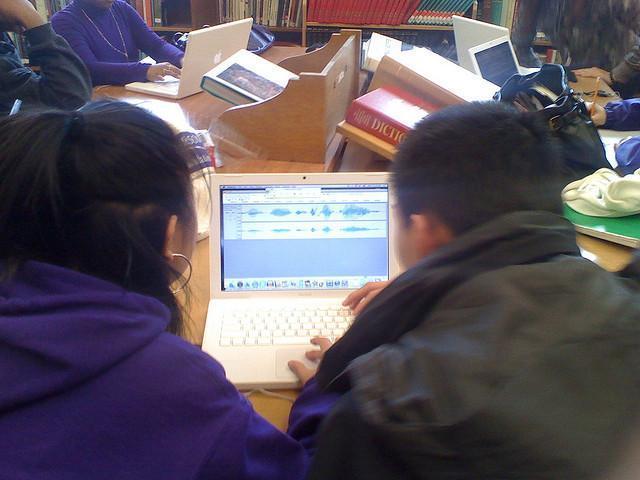How many computers?
Give a very brief answer. 4. How many dictionaries are in the photo?
Give a very brief answer. 1. How many people are there?
Give a very brief answer. 5. How many books are visible?
Give a very brief answer. 3. How many handbags are there?
Give a very brief answer. 2. How many laptops are visible?
Give a very brief answer. 2. 